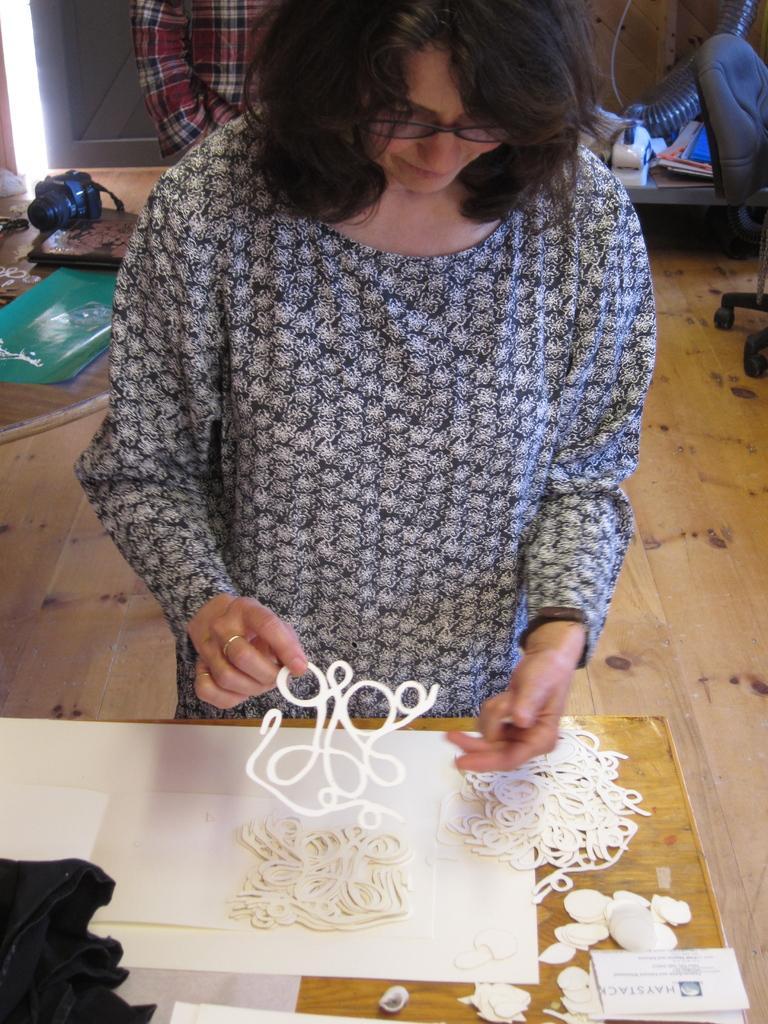Could you give a brief overview of what you see in this image? In this image we can see two persons, among them one person is holding an object, there is a table with some objects on it and we can see some other objects on the floor. 